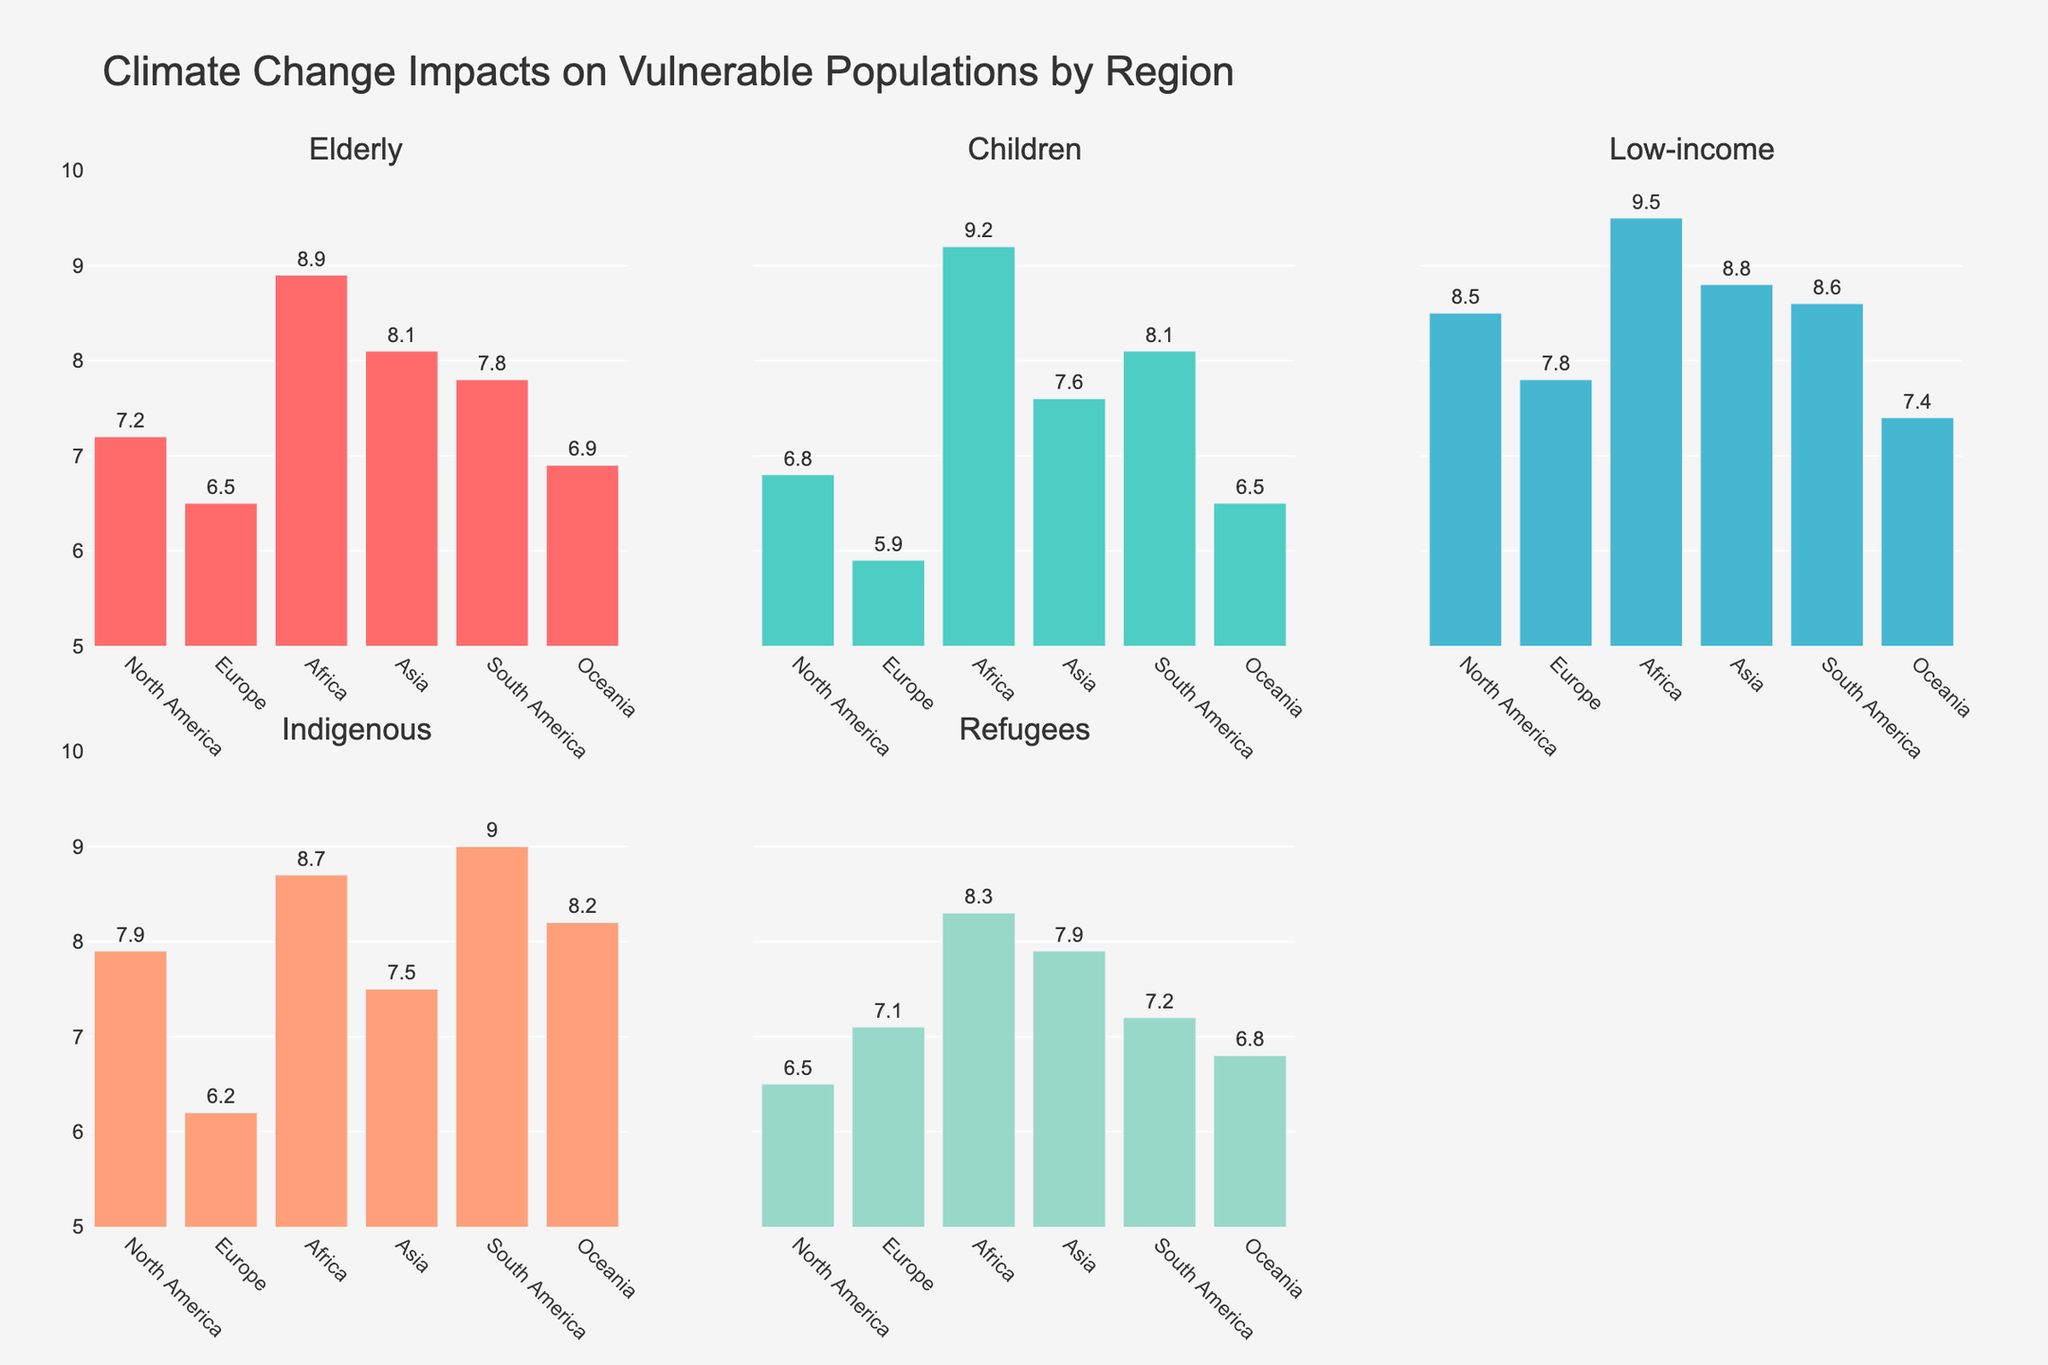What is the title of the figure? The title is located at the top of the figure. It is 'Climate Change Impacts on Vulnerable Populations by Region'.
Answer: Climate Change Impacts on Vulnerable Populations by Region Which group shows the highest impact in Africa? In the Africa subplot, the highest bar belongs to the 'Low-income' group with a value of 9.5.
Answer: Low-income Which region has the lowest impact on the elderly population? In the Elderly subplot, the lowest bar belongs to Europe with a value of 6.5.
Answer: Europe What is the average impact score for the Refugees group across all regions? The values for the Refugees group are 6.5, 7.1, 8.3, 7.9, 7.2, and 6.8. Summing them gives 43.8. Dividing by the number of regions (6) gives: 43.8 / 6 = 7.3.
Answer: 7.3 How does the impact on Indigenous populations in South America compare to that in North America? In the Indigenous subplot, South America has an impact score of 9.0, while North America has a score of 7.9. 9.0 is greater than 7.9.
Answer: South America’s impact is higher Which vulnerable group faces the least impact in Oceania? In the Oceania subplot, the 'Children' group has the lowest bar with a value of 6.5.
Answer: Children What is the difference in the impact scores for the Low-income group between Africa and Europe? The Low-income group scores are 9.5 for Africa and 7.8 for Europe. The difference is 9.5 - 7.8 = 1.7.
Answer: 1.7 What is the combined impact score for Elderly and Children in North America? The Elderly score in North America is 7.2, and the Children score is 6.8. The combined score is 7.2 + 6.8 = 14.
Answer: 14 Which region shows the highest overall impact across all vulnerable groups? Summing the impact scores for each region:
North America: 7.2 + 6.8 + 8.5 + 7.9 + 6.5 = 36.9.
Europe: 6.5 + 5.9 + 7.8 + 6.2 + 7.1 = 33.5.
Africa: 8.9 + 9.2 + 9.5 + 8.7 + 8.3 = 44.6.
Asia: 8.1 + 7.6 + 8.8 + 7.5 + 7.9 = 39.9.
South America: 7.8 + 8.1 + 8.6 + 9.0 + 7.2 = 40.7.
Oceania: 6.9 + 6.5 + 7.4 + 8.2 + 6.8 = 35.8.
Africa has the highest overall impact score of 44.6.
Answer: Africa Which vulnerable group has the most consistent impact across all regions? The scores for each group across regions:
Elderly: 7.2, 6.5, 8.9, 8.1, 7.8, 6.9. Range = 8.9 - 6.5 = 2.4.
Children: 6.8, 5.9, 9.2, 7.6, 8.1, 6.5. Range = 9.2 - 5.9 = 3.3.
Low-income: 8.5, 7.8, 9.5, 8.8, 8.6, 7.4. Range = 9.5 - 7.4 = 2.1.
Indigenous: 7.9, 6.2, 8.7, 7.5, 9.0, 8.2. Range = 9.0 - 6.2 = 2.8.
Refugees: 6.5, 7.1, 8.3, 7.9, 7.2, 6.8. Range = 8.3 - 6.5 = 1.8.
'Refugees' has the smallest range (1.8), indicating the most consistent impact.
Answer: Refugees 